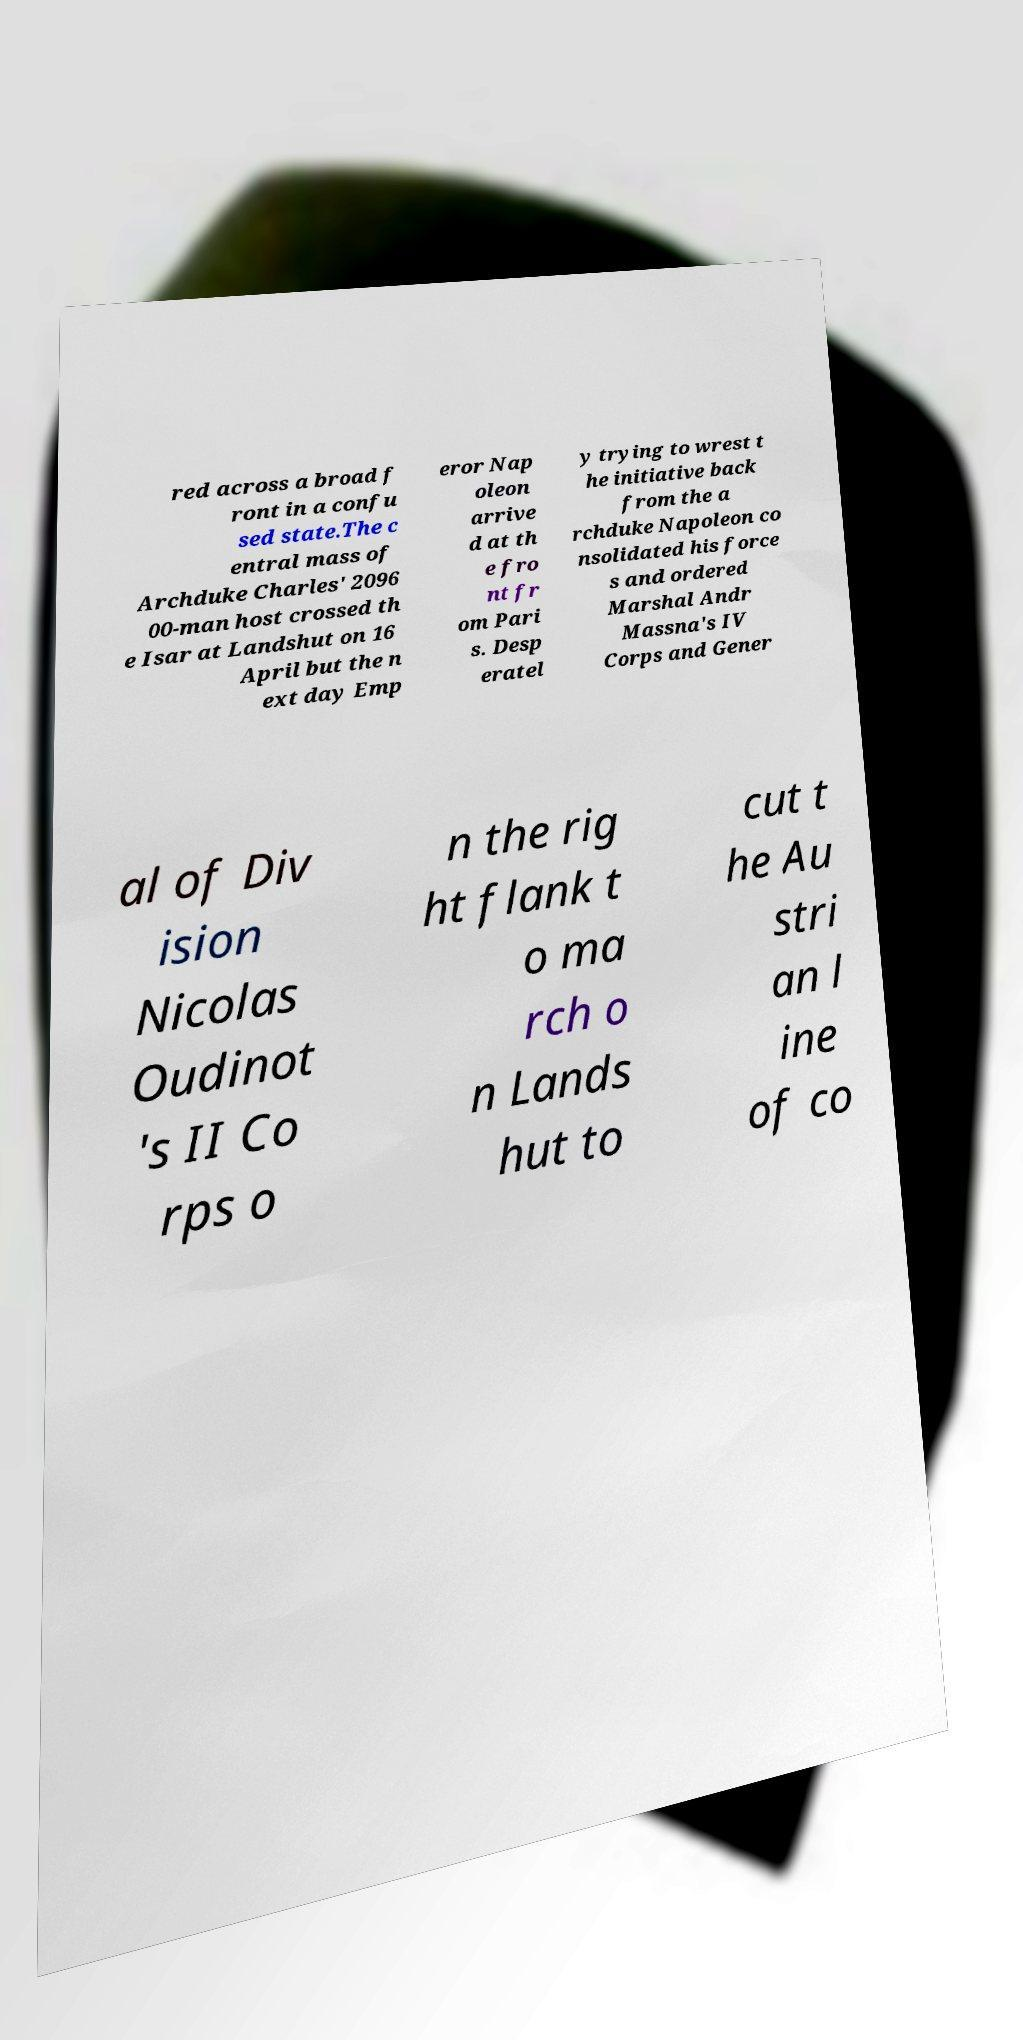Could you assist in decoding the text presented in this image and type it out clearly? red across a broad f ront in a confu sed state.The c entral mass of Archduke Charles' 2096 00-man host crossed th e Isar at Landshut on 16 April but the n ext day Emp eror Nap oleon arrive d at th e fro nt fr om Pari s. Desp eratel y trying to wrest t he initiative back from the a rchduke Napoleon co nsolidated his force s and ordered Marshal Andr Massna's IV Corps and Gener al of Div ision Nicolas Oudinot 's II Co rps o n the rig ht flank t o ma rch o n Lands hut to cut t he Au stri an l ine of co 